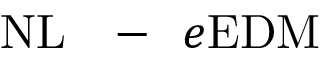<formula> <loc_0><loc_0><loc_500><loc_500>N L { - } e E D M</formula> 